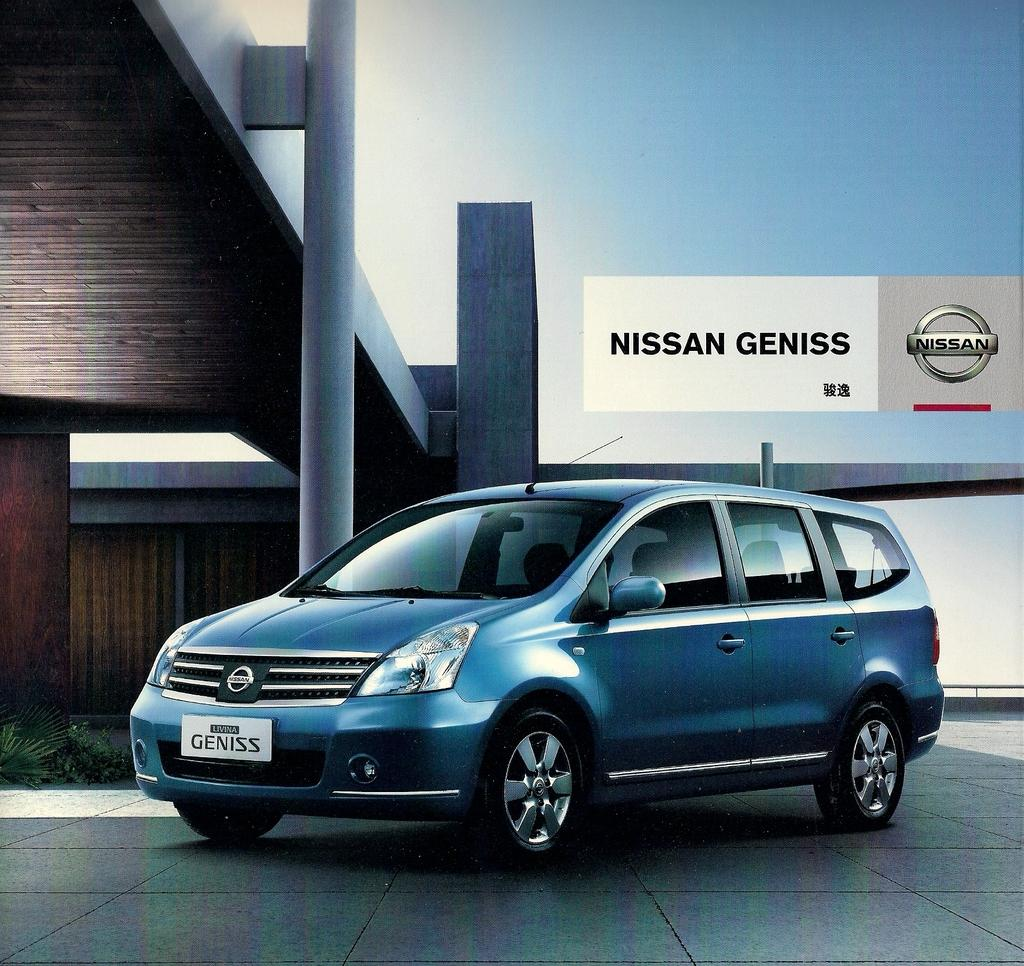Provide a one-sentence caption for the provided image. A blue Nissan Geniss is displayed in a showroom. 